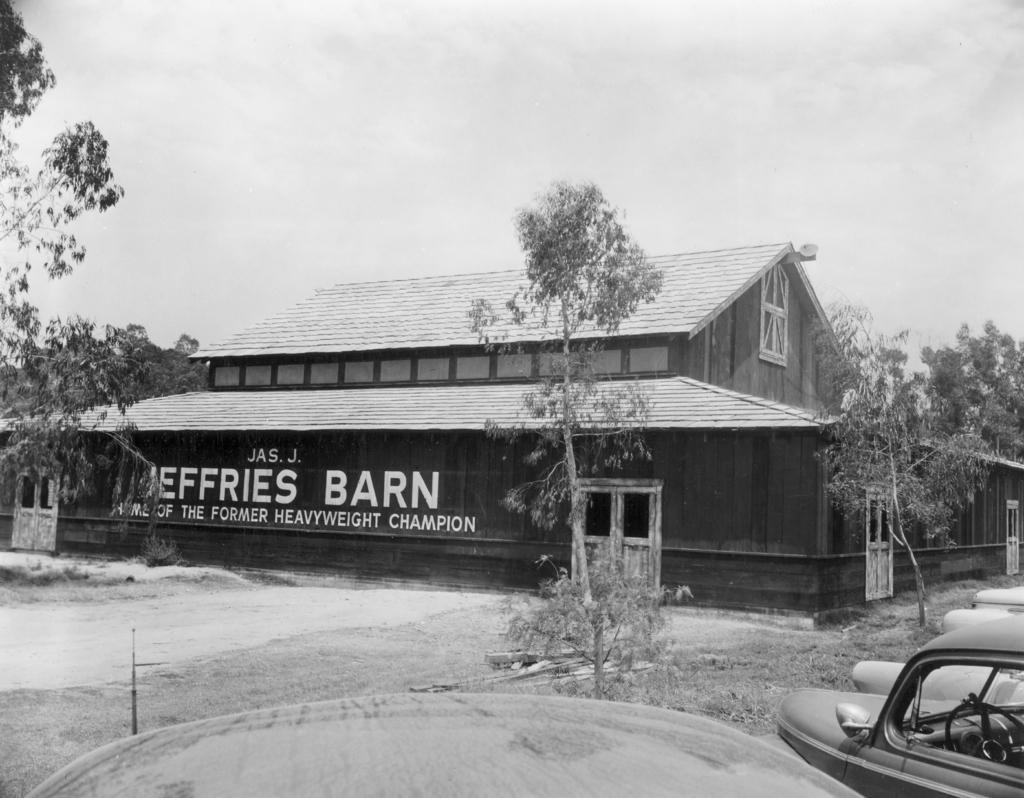Could you give a brief overview of what you see in this image? This is black and white picture, in this picture we can see vehicle and objects. We can see ground, trees, grass and house. In the background of the image we can see the sky. 